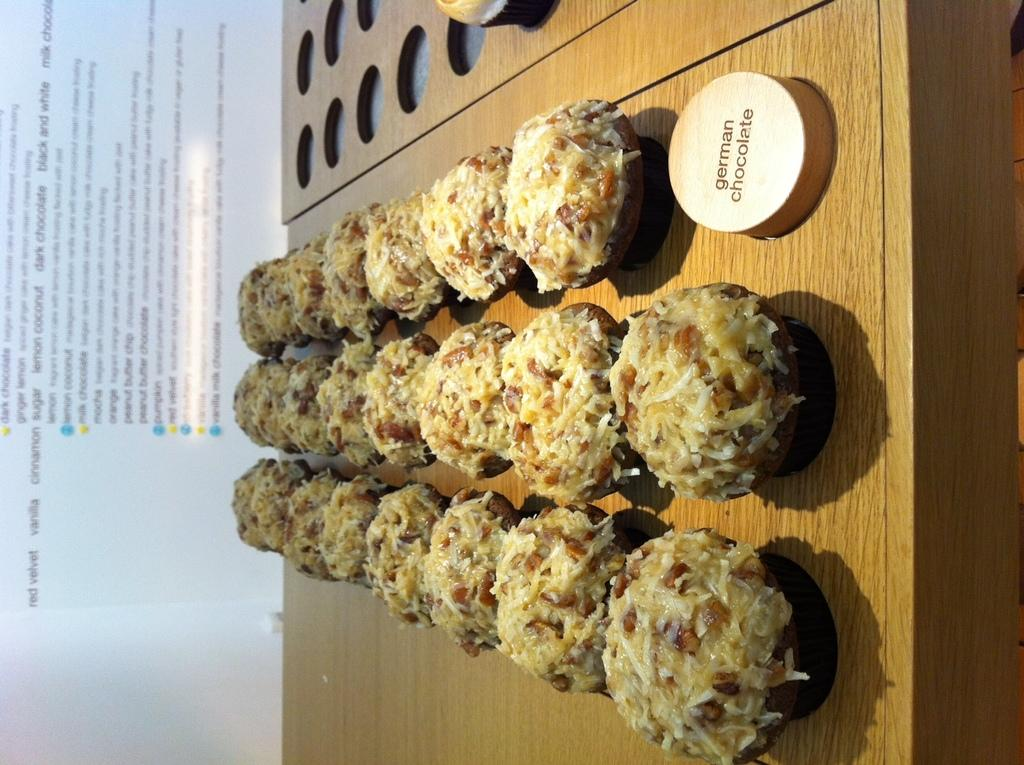What is placed on the table in the image? There is food placed on a table in the image. What object with text can be seen in the image? There is a piece of wood with text in the image. Can you read the text on the backside of the piece of wood? Yes, there is text visible on the backside of the piece of wood. How many babies are sitting on the leaf in the image? There is no leaf or babies present in the image. 